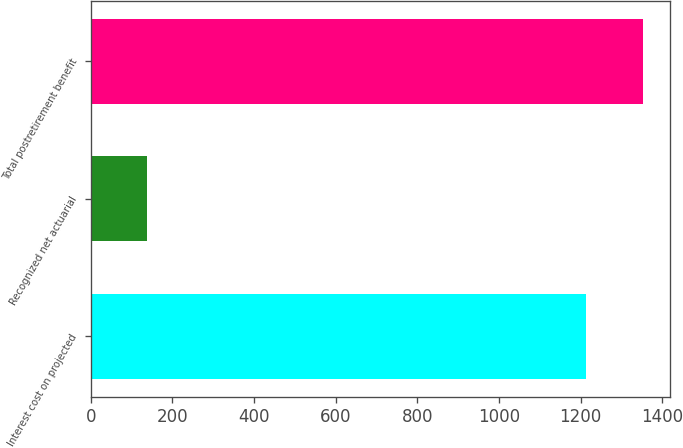Convert chart to OTSL. <chart><loc_0><loc_0><loc_500><loc_500><bar_chart><fcel>Interest cost on projected<fcel>Recognized net actuarial<fcel>Total postretirement benefit<nl><fcel>1213<fcel>139<fcel>1352<nl></chart> 